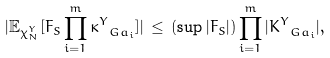<formula> <loc_0><loc_0><loc_500><loc_500>| \mathbb { E } _ { \chi _ { N } ^ { Y } } [ F _ { S } \prod _ { i = 1 } ^ { m } \kappa _ { \ G a _ { i } } ^ { Y } ] | \, \leq \, ( \sup | F _ { S } | ) \prod _ { i = 1 } ^ { m } | K ^ { Y } _ { \ G a _ { i } } | ,</formula> 